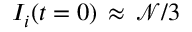Convert formula to latex. <formula><loc_0><loc_0><loc_500><loc_500>I _ { i } ( t = 0 ) \, \approx \, \mathcal { N } / 3</formula> 